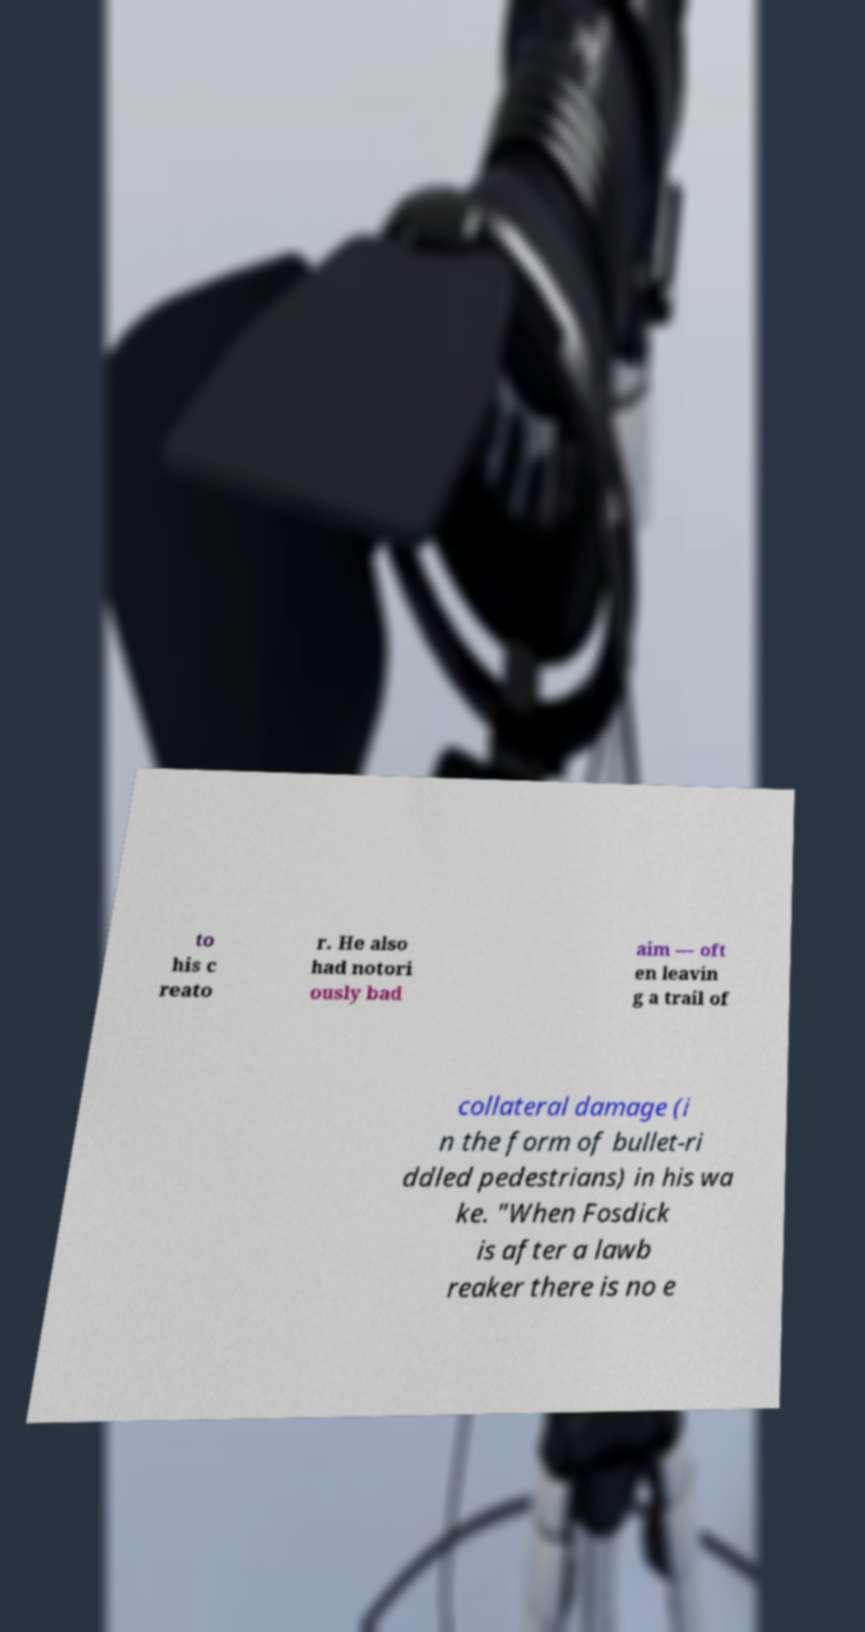Can you read and provide the text displayed in the image?This photo seems to have some interesting text. Can you extract and type it out for me? to his c reato r. He also had notori ously bad aim — oft en leavin g a trail of collateral damage (i n the form of bullet-ri ddled pedestrians) in his wa ke. "When Fosdick is after a lawb reaker there is no e 